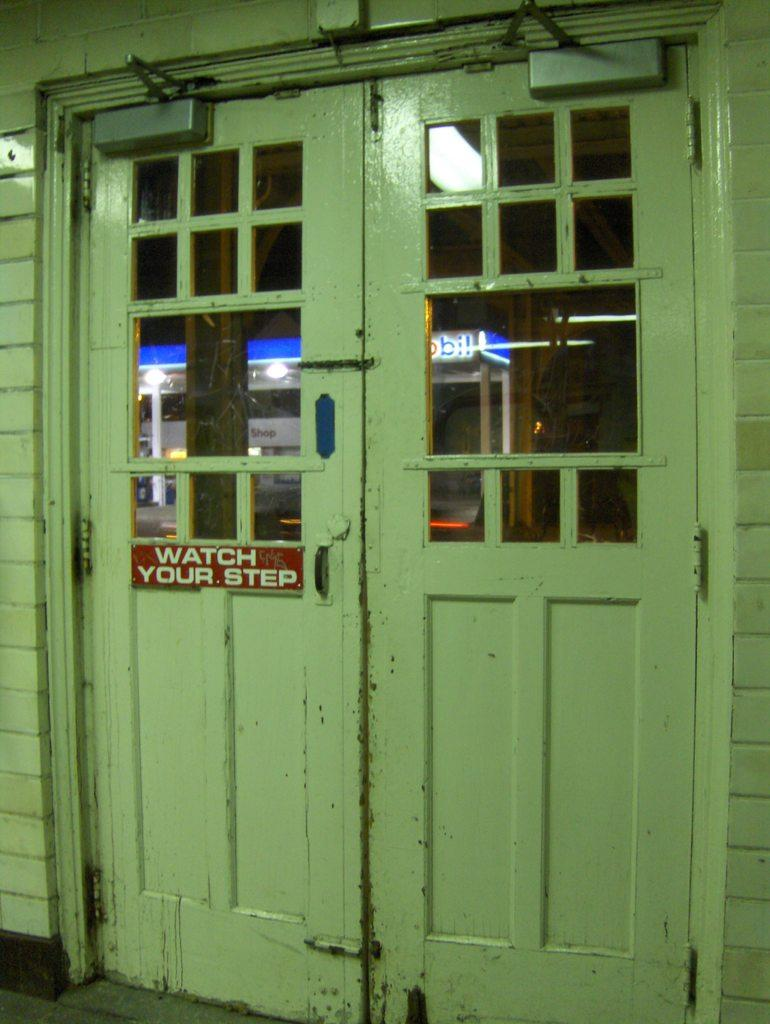What is the color of the building in the image? The building in the image is green. What is the color of the doors in the image? The doors in the image are also green. What is attached to the building and what is its color? There is a red color board attached to the building. Can you tell me how many necks are visible in the image? There are no necks visible in the image. Is there any mention of payment in the image? There is no mention of payment in the image. 